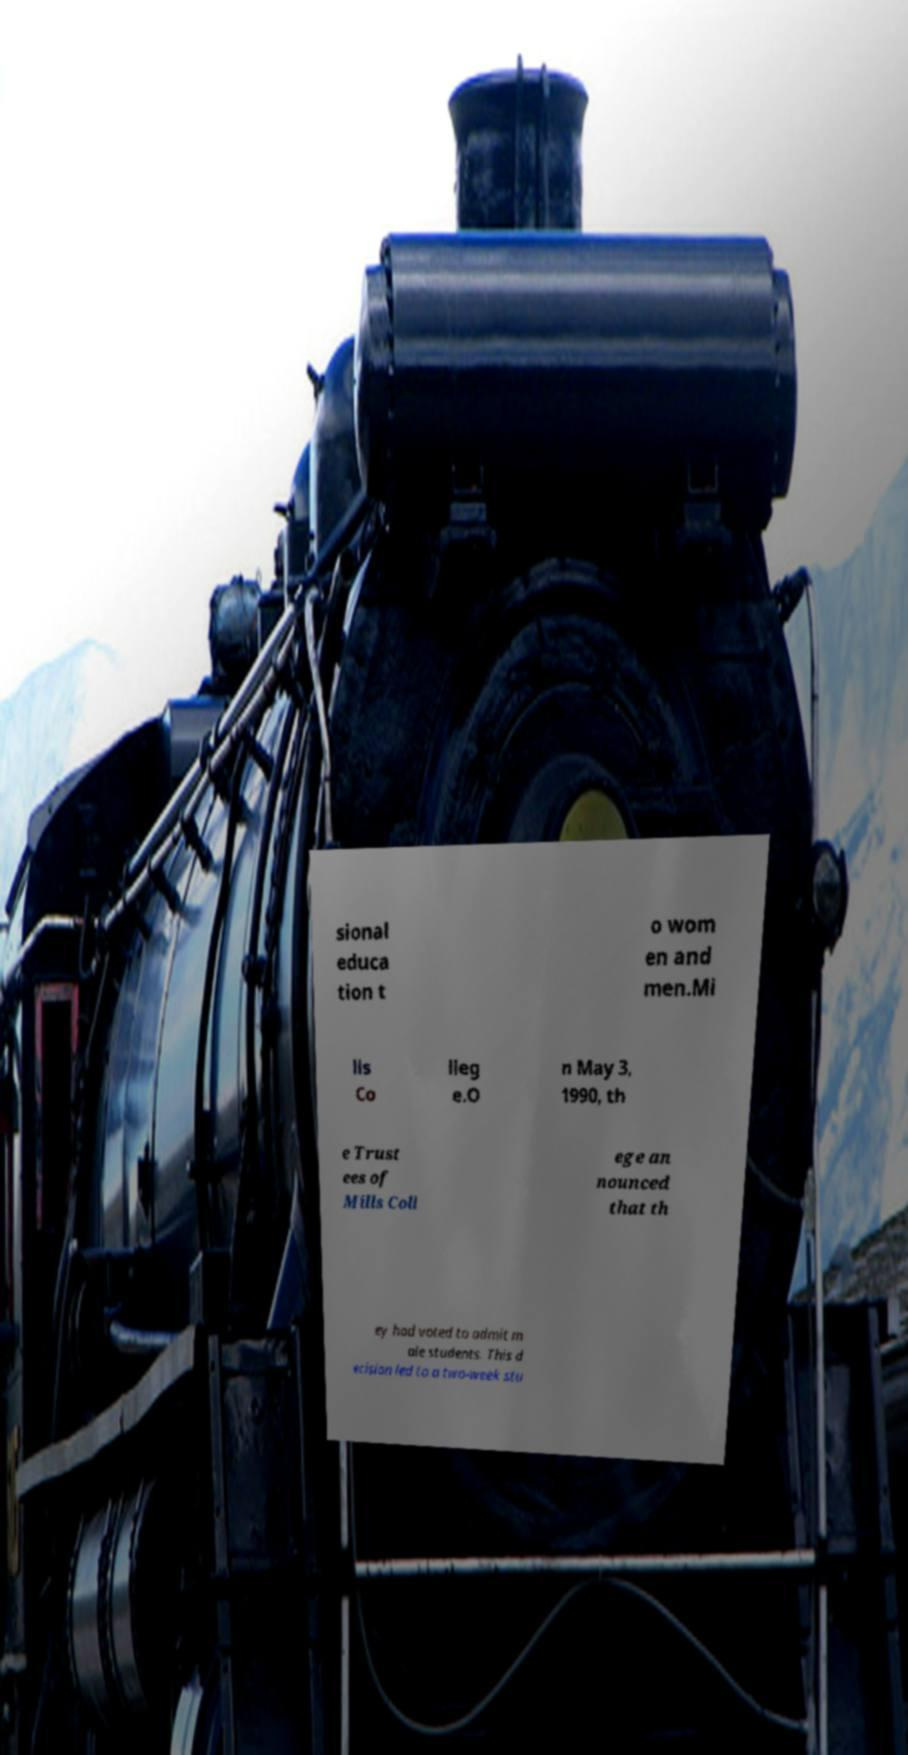There's text embedded in this image that I need extracted. Can you transcribe it verbatim? sional educa tion t o wom en and men.Mi lls Co lleg e.O n May 3, 1990, th e Trust ees of Mills Coll ege an nounced that th ey had voted to admit m ale students. This d ecision led to a two-week stu 